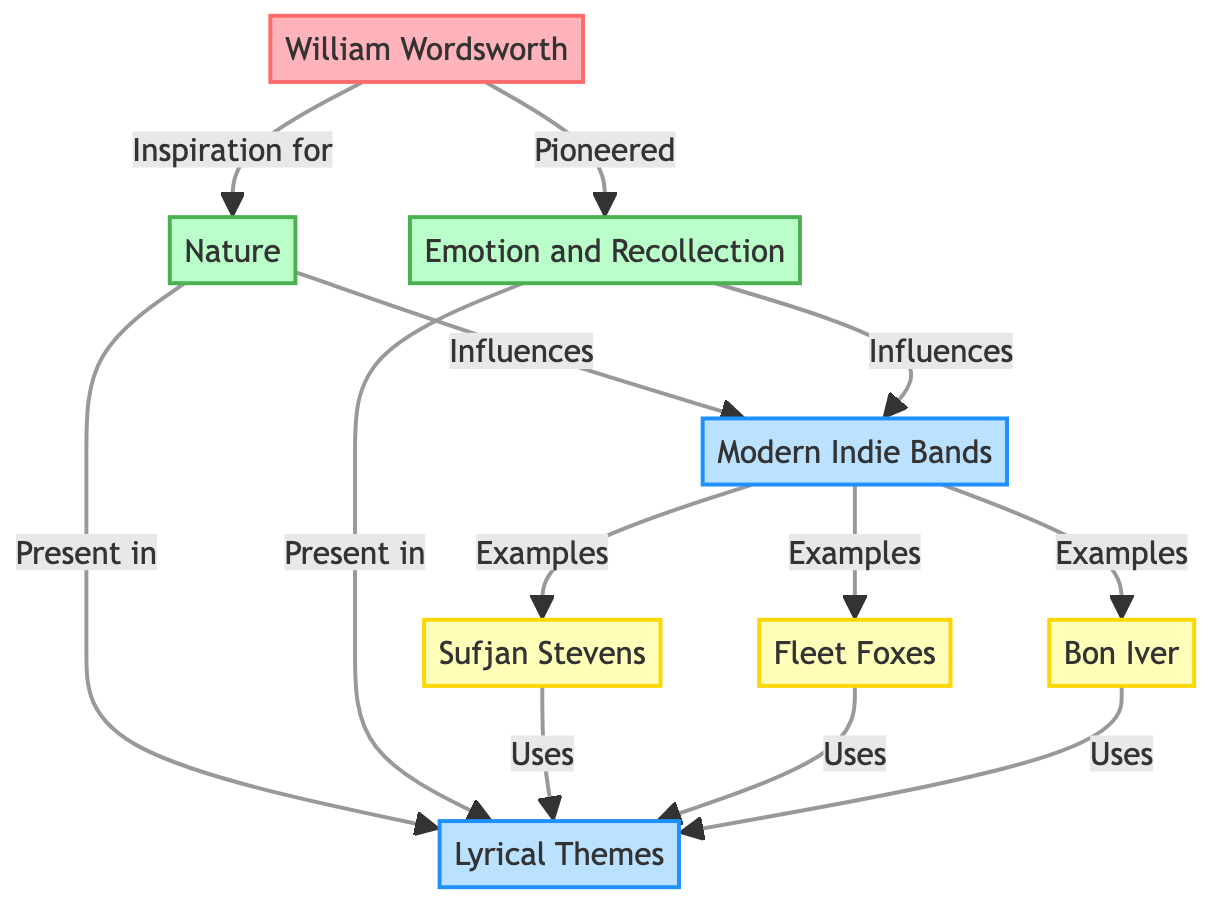What is the name of the poet influencing modern indie music? The diagram shows that "William Wordsworth" is the primary poet referenced, as indicated by the connection labeled "Inspiration for."
Answer: William Wordsworth How many themes are directly associated with William Wordsworth? The diagram connects William Wordsworth to two themes: "Nature" and "Emotion and Recollection," indicating there are two themes associated with him.
Answer: 2 Which modern indie band is an example of the influence of nature? The arrow points from "Nature" to "Modern Indie Bands," and within that category, "Sufjan Stevens," "Fleet Foxes," and "Bon Iver" are examples, but since the question asks for a single example, we can use the first listed.
Answer: Sufjan Stevens What are the labels of the two themes pioneered by William Wordsworth? The diagram specifies two labels from William Wordsworth to the themes: "Nature" and "Emotion and Recollection." Therefore, we can list both labels as they specifically represent Wordsworth's contributions.
Answer: Nature, Emotion and Recollection How many artists use lyrical themes related to the influence of Wordsworth's emotions? The edge labeled "Presents in" from "Emotion and Recollection" to "Lyrical Themes" indicates the presence of this theme, and the subsequent connections from each artist ("Sufjan Stevens," "Fleet Foxes," "Bon Iver") indicate they all use these themes. There are three artists connected to this.
Answer: 3 Which category encompasses the artists influenced by Wordsworth's themes? The diagram shows that both "Modern Indie Bands" category and "Lyrical Themes" encompass various artists, which suggests that the artists belong to the "Modern Indie Bands" category specifically influenced by Wordsworth.
Answer: Modern Indie Bands What influences connect to lyrical themes according to the diagram? The edges labeled "Present in" indicate that both "Nature" and "Emotion and Recollection" have connections to the "Lyrical Themes," meaning both themes influence lyrical writing.
Answer: Nature, Emotion and Recollection How many edges connect William Wordsworth to themes? The diagram shows two direct connections, one to "Nature" and one to "Emotion and Recollection," indicating two edges are connected to him.
Answer: 2 Which theme is specifically labeled as being pioneered by Wordsworth? Among the two themes associated with Wordsworth, the edge indicates that "Emotion and Recollection" is specifically labeled as "Pioneered."
Answer: Emotion and Recollection 